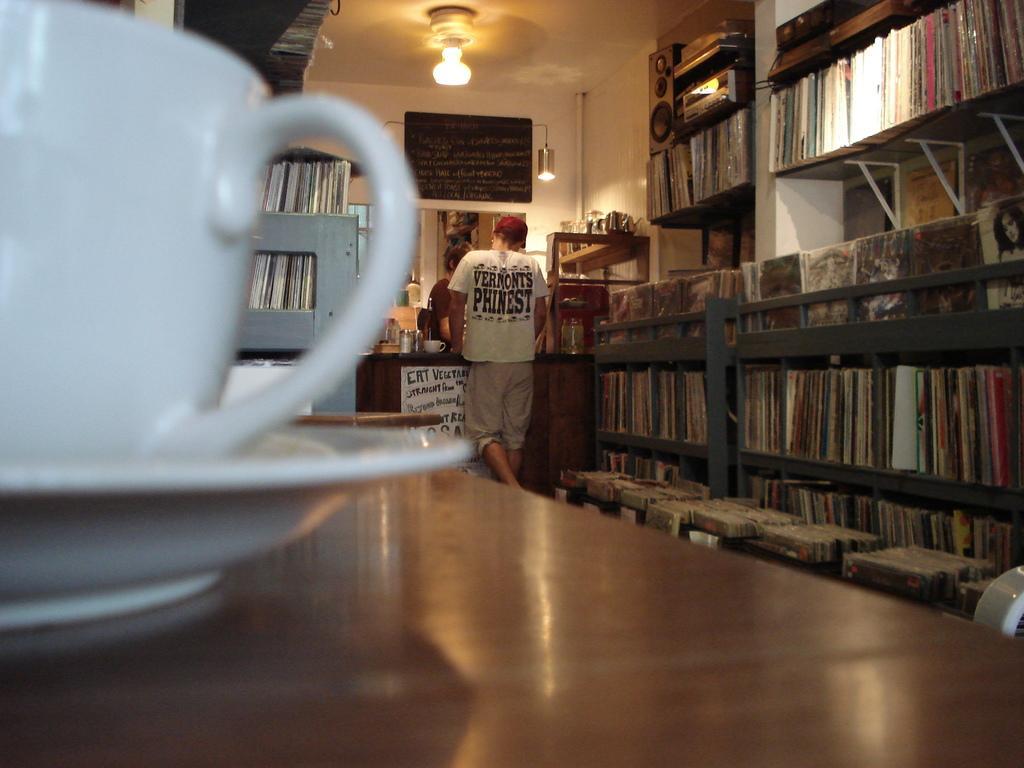How would you summarize this image in a sentence or two? This image consists of book racks in which there are so many books. There is a light on the top and there is a black board on the top. There are two persons standing, in between them there is a table and on the table there is a cup, jar. There is a table in the front on which there is a cup and saucer. 